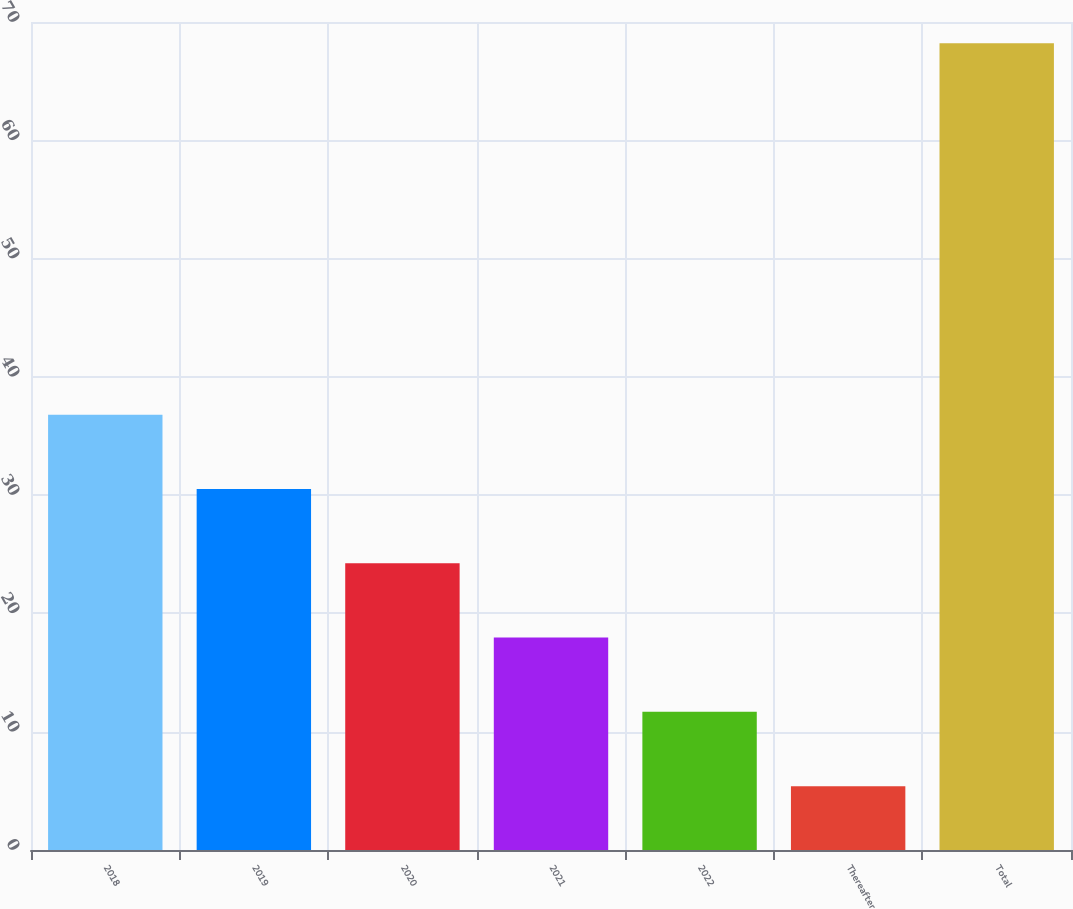Convert chart to OTSL. <chart><loc_0><loc_0><loc_500><loc_500><bar_chart><fcel>2018<fcel>2019<fcel>2020<fcel>2021<fcel>2022<fcel>Thereafter<fcel>Total<nl><fcel>36.8<fcel>30.52<fcel>24.24<fcel>17.96<fcel>11.68<fcel>5.4<fcel>68.2<nl></chart> 